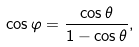<formula> <loc_0><loc_0><loc_500><loc_500>\cos \varphi & = \frac { \cos \theta } { 1 - \cos \theta } ,</formula> 